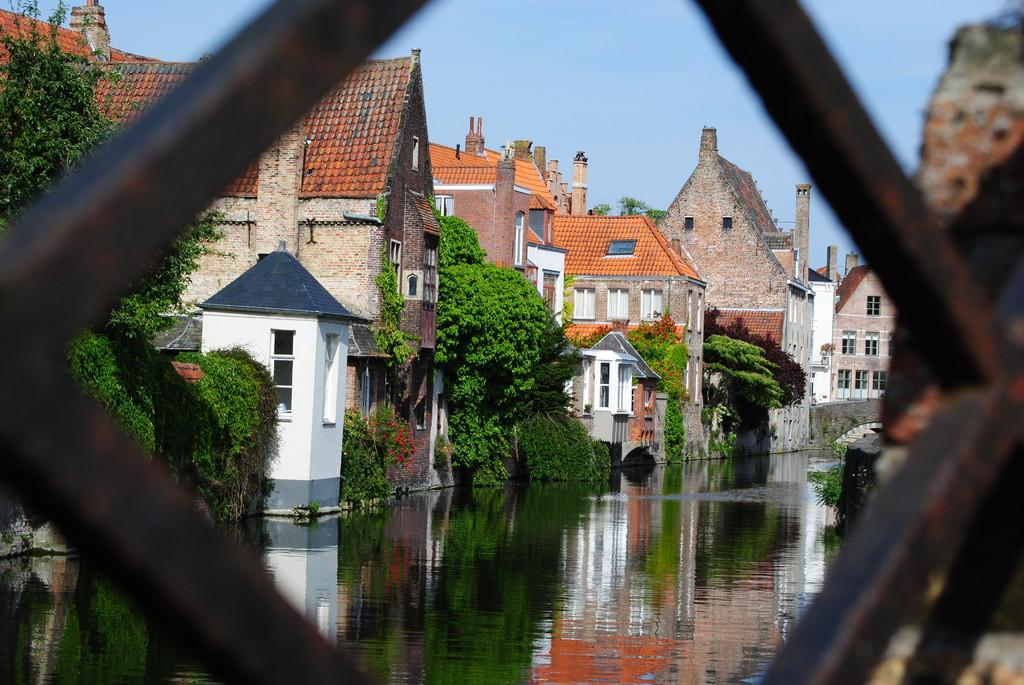What type of structure can be seen in the image? There is a fence in the image. What natural element is visible in the image? There is water visible in the image. What is growing on the houses in the image? There are plants on the houses. What can be observed on the water's surface in the image? Reflections are visible on the water. What type of harmony can be heard in the image? There is no audible sound in the image, so it's not possible to determine if there is any harmony present. What type of underwear is visible on the plants in the image? There are no underwear items present in the image; it features a fence, water, and plants on houses. 